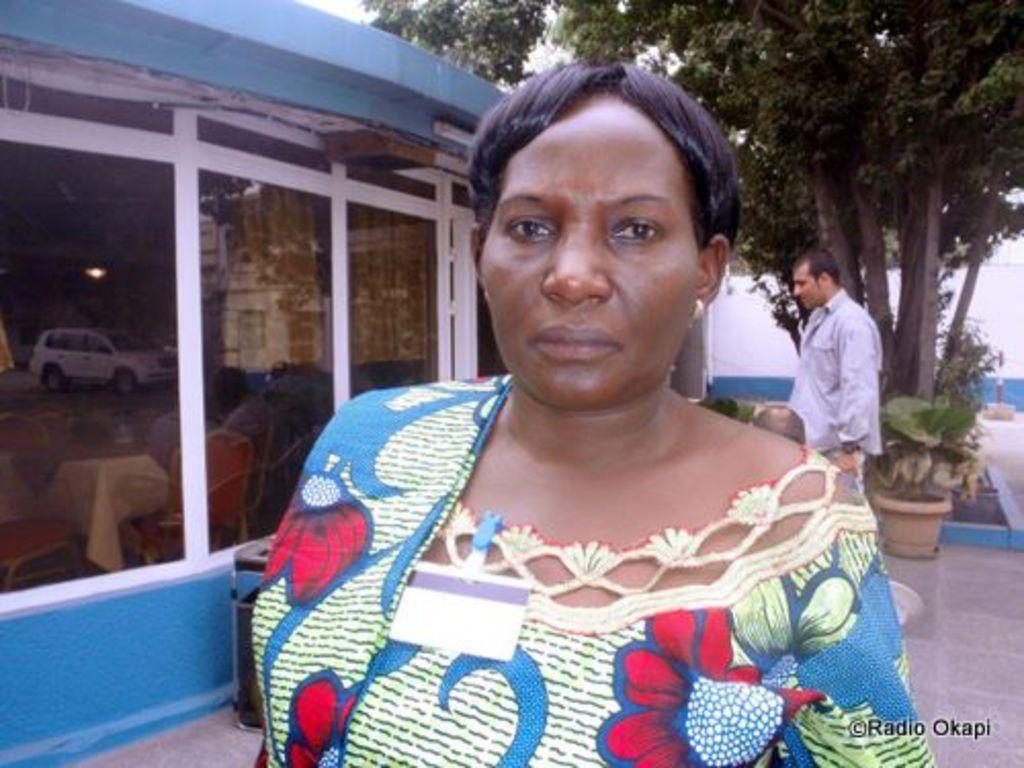Please provide a concise description of this image. In this image we can see a woman and a man standing on the floor. In the background we can see trees, houseplants, buildings and sky. 